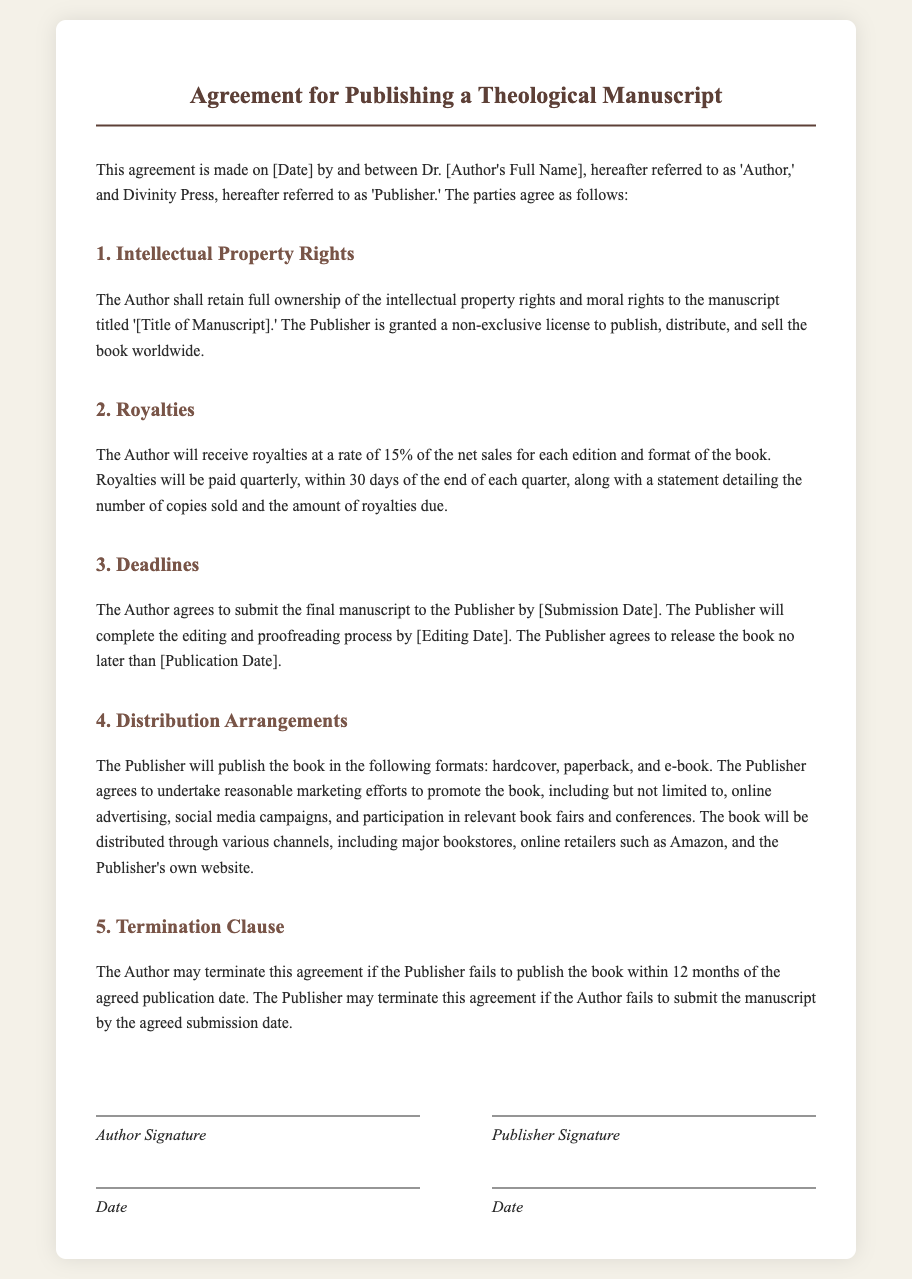What is the author's name? The author's name is the individual referred to as 'Author' in the contract, which is Dr. [Author's Full Name].
Answer: Dr. [Author's Full Name] What is the royalty rate for the author? The document states that the author will receive royalties at a rate of 15% of the net sales for each edition and format of the book.
Answer: 15% When is the manuscript submission deadline? The manuscript submission deadline is specified as [Submission Date].
Answer: [Submission Date] How long does the Publisher have to pay royalties? The Publisher has a timeframe of 30 days after the end of each quarter to pay royalties.
Answer: 30 days What are the formats in which the book will be published? The document outlines that the book will be published in hardcover, paperback, and e-book formats.
Answer: hardcover, paperback, e-book What happens if the Publisher fails to publish the book on time? The Author may terminate the agreement if the Publisher fails to publish the book within 12 months of the agreed publication date.
Answer: Terminate the agreement What are some marketing efforts mentioned for promoting the book? The document lists online advertising, social media campaigns, and participation in book fairs as marketing efforts for promotion.
Answer: online advertising, social media campaigns, book fairs What is the title of the manuscript? The title of the manuscript is referred to as '[Title of Manuscript]' in the agreement.
Answer: [Title of Manuscript] 